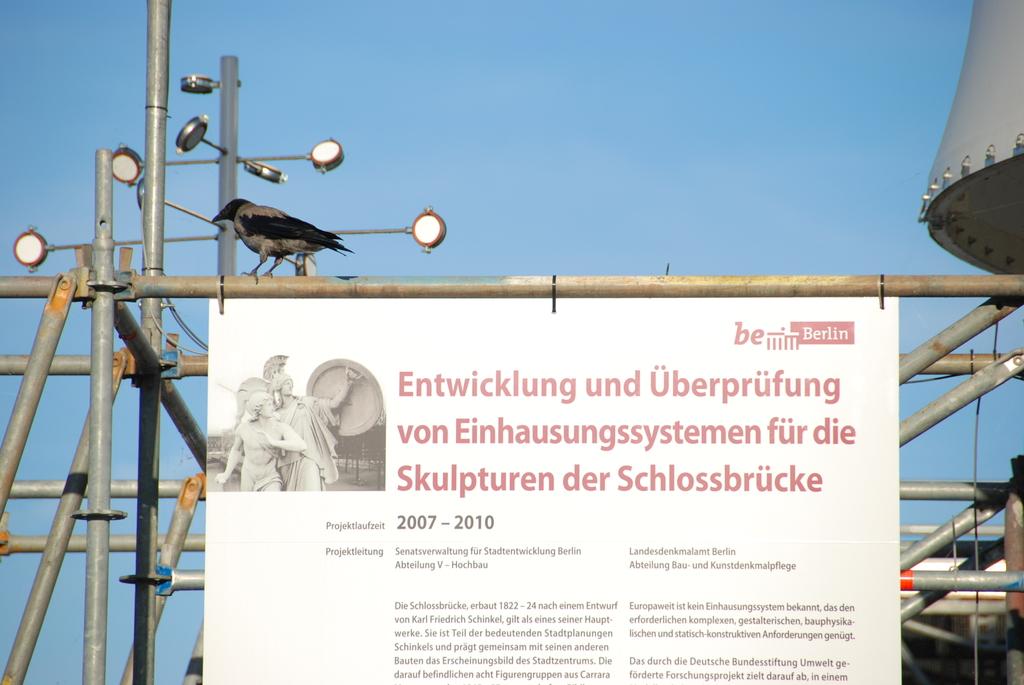What years are posted here?
Your answer should be very brief. 2007-2010. How many big words are there?
Your response must be concise. 10. 